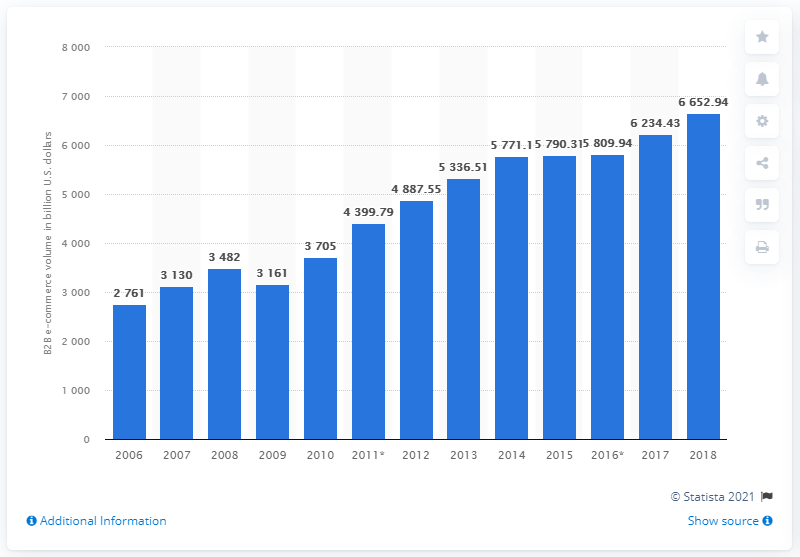List a handful of essential elements in this visual. In 2018, the total amount of combined manufacturing and merchant wholesale e-commerce revenue in the United States was approximately 6,652.94. 